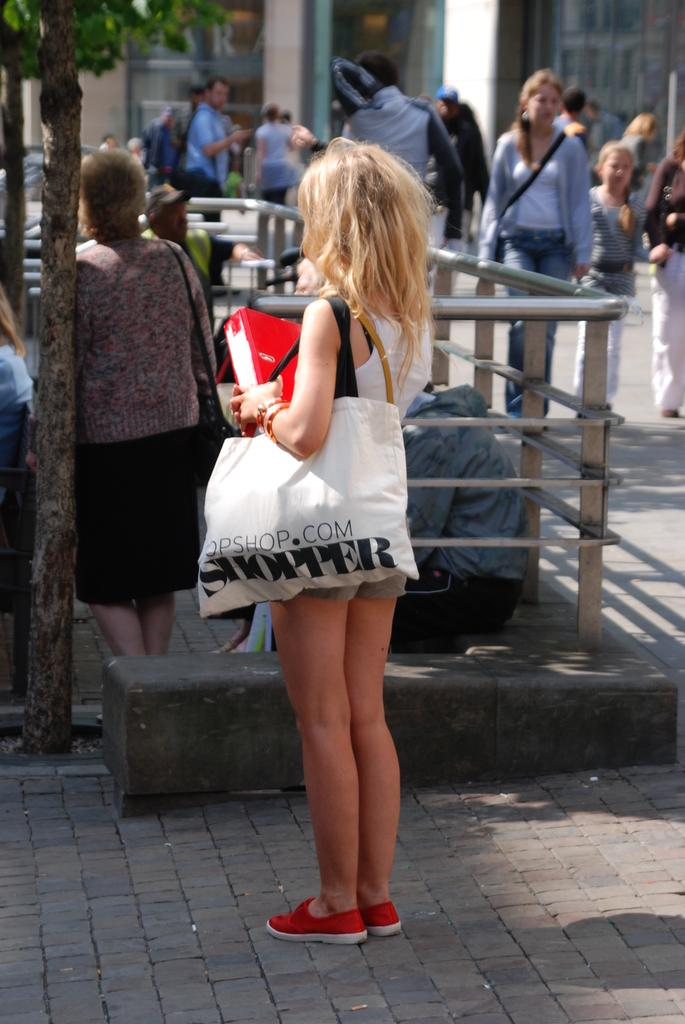Provide a one-sentence caption for the provided image. A woman carrying a large bag with the word SHOPPER printed on it walks down a busy street. 